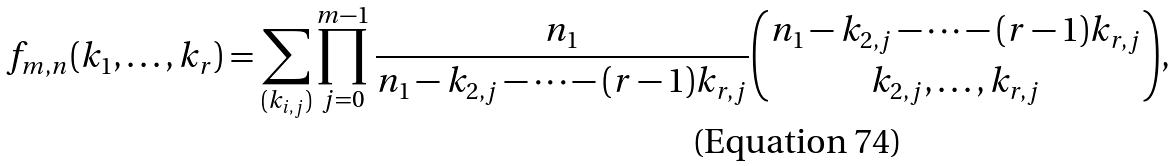Convert formula to latex. <formula><loc_0><loc_0><loc_500><loc_500>f _ { m , n } ( k _ { 1 } , \dots , k _ { r } ) = \sum _ { ( k _ { i , j } ) } \prod _ { j = 0 } ^ { m - 1 } \frac { n _ { 1 } } { n _ { 1 } - k _ { 2 , j } - \cdots - ( r - 1 ) k _ { r , j } } { n _ { 1 } - k _ { 2 , j } - \cdots - ( r - 1 ) k _ { r , j } \choose k _ { 2 , j } , \dots , k _ { r , j } } ,</formula> 